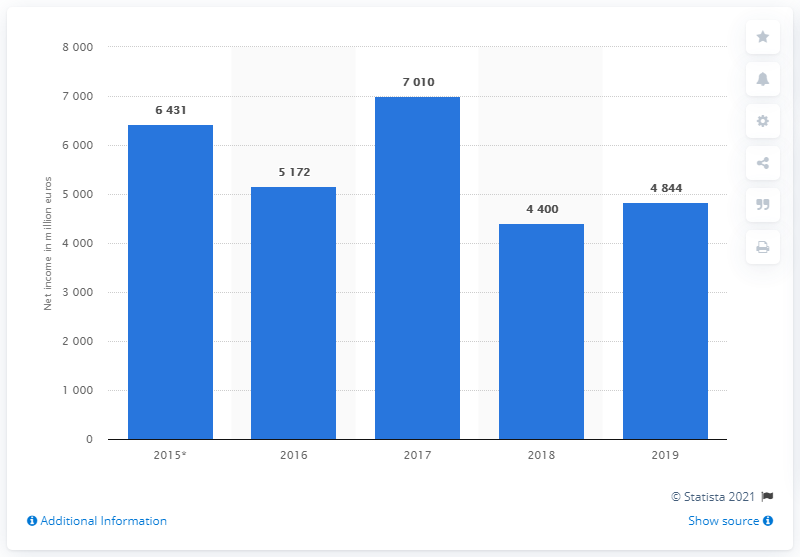List a handful of essential elements in this visual. The net income of Credit Agricole in 2019 was 4,844. The net income of Credit Agricole in 2018 was 4,400. 